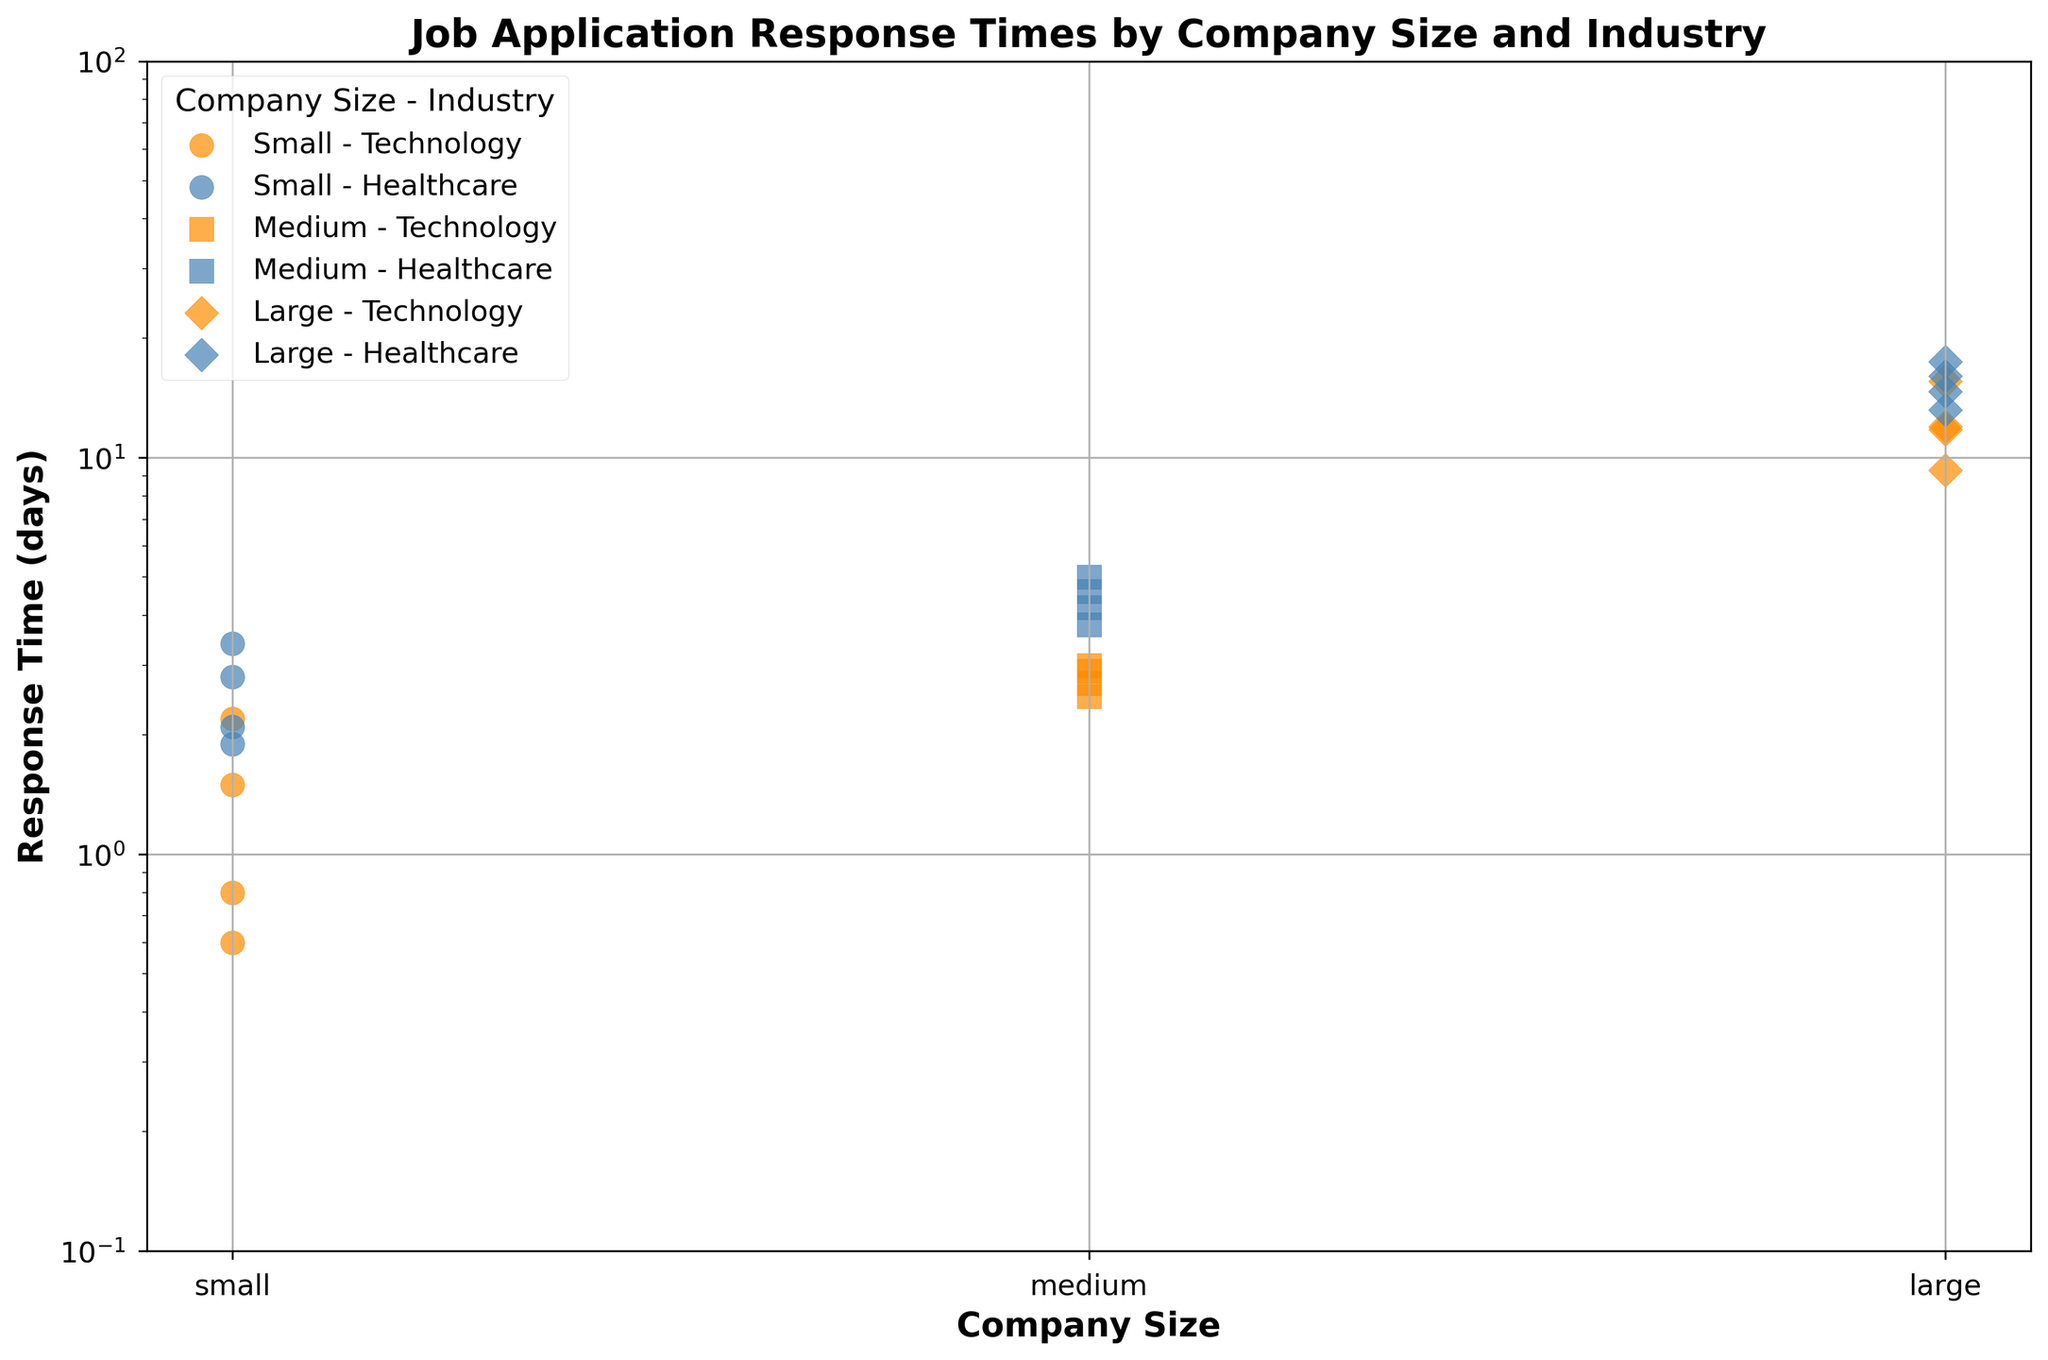What is the general trend of response times for large companies in the healthcare industry? Observing the scatter plot markers for large companies in healthcare (steel blue diamonds), it is clear that the response times mostly fall between 13.2 and 17.5 days. This suggests that larger healthcare companies generally take longer to respond to job applications.
Answer: Longer response times Which industry shows a quicker response time for small companies? By looking at the scatter markers for small companies (orange circles for technology and blue circles for healthcare), we see that technology response times (0.6 to 2.2 days) are generally shorter than healthcare response times (1.9 to 3.4 days).
Answer: Technology What is the range of response times for medium-sized technology companies? Medium-sized technology companies show scatter markers (orange squares) ranging from 2.5 to 3.0 days. Calculating these values, we get a range of 3.0 days - 2.5 days, which is 0.5 days.
Answer: 0.5 days Do small-sized companies have more varied response times in technology or healthcare? By observing the scatter markers, small technology companies range from 0.6 to 2.2 days (variance = 2.2 - 0.6 = 1.6 days), while small healthcare companies range from 1.9 to 3.4 days (variance = 3.4 - 1.9 = 1.5 days). The variance is slightly larger for technology.
Answer: Technology What is the pattern of response times between technology and healthcare for medium companies? Looking at the scatter plot, medium-sized technology companies (orange squares) have a response time range between 2.5 and 3.0 days. In contrast, medium-sized healthcare companies (blue squares) range between 3.8 and 5.0 days. This indicates that technology companies have a shorter and more clustered response time than healthcare companies.
Answer: Technology is shorter and more clustered How do response times for large companies compare between technology and healthcare industries? Observing the scatter plot markers for large companies (orange diamonds for technology and blue diamonds for healthcare), technology response times range from 9.3 to 15.6 days, while healthcare response times range from 13.2 to 17.5 days. This indicates that large companies in the healthcare industry generally have longer response times than those in technology.
Answer: Healthcare is longer Are small healthcare companies generally faster in responding than medium healthcare companies? Small healthcare companies have response times between 1.9 to 3.4 days. For medium healthcare companies, response times range from 3.8 to 5.0 days. Since the smallest value in medium companies (3.8 days) is higher than the largest in small companies (3.4 days), small companies are generally faster.
Answer: Yes Which category has the longest response time overall? Observing the maximum response times in the scatter plot for all categories, the largest value appears in large healthcare companies with a maximum of 17.5 days.
Answer: Large healthcare Do medium companies in technology have more consistent response times compared to healthcare? Reviewing the scatter plot markers, medium technology companies (orange squares) have response times ranging from 2.5 to 3.0 days, which is a very narrow range. Conversely, medium healthcare companies (blue squares) range from 3.8 to 5.0 days, showing more variation. Thus, technology companies are more consistent.
Answer: Yes 